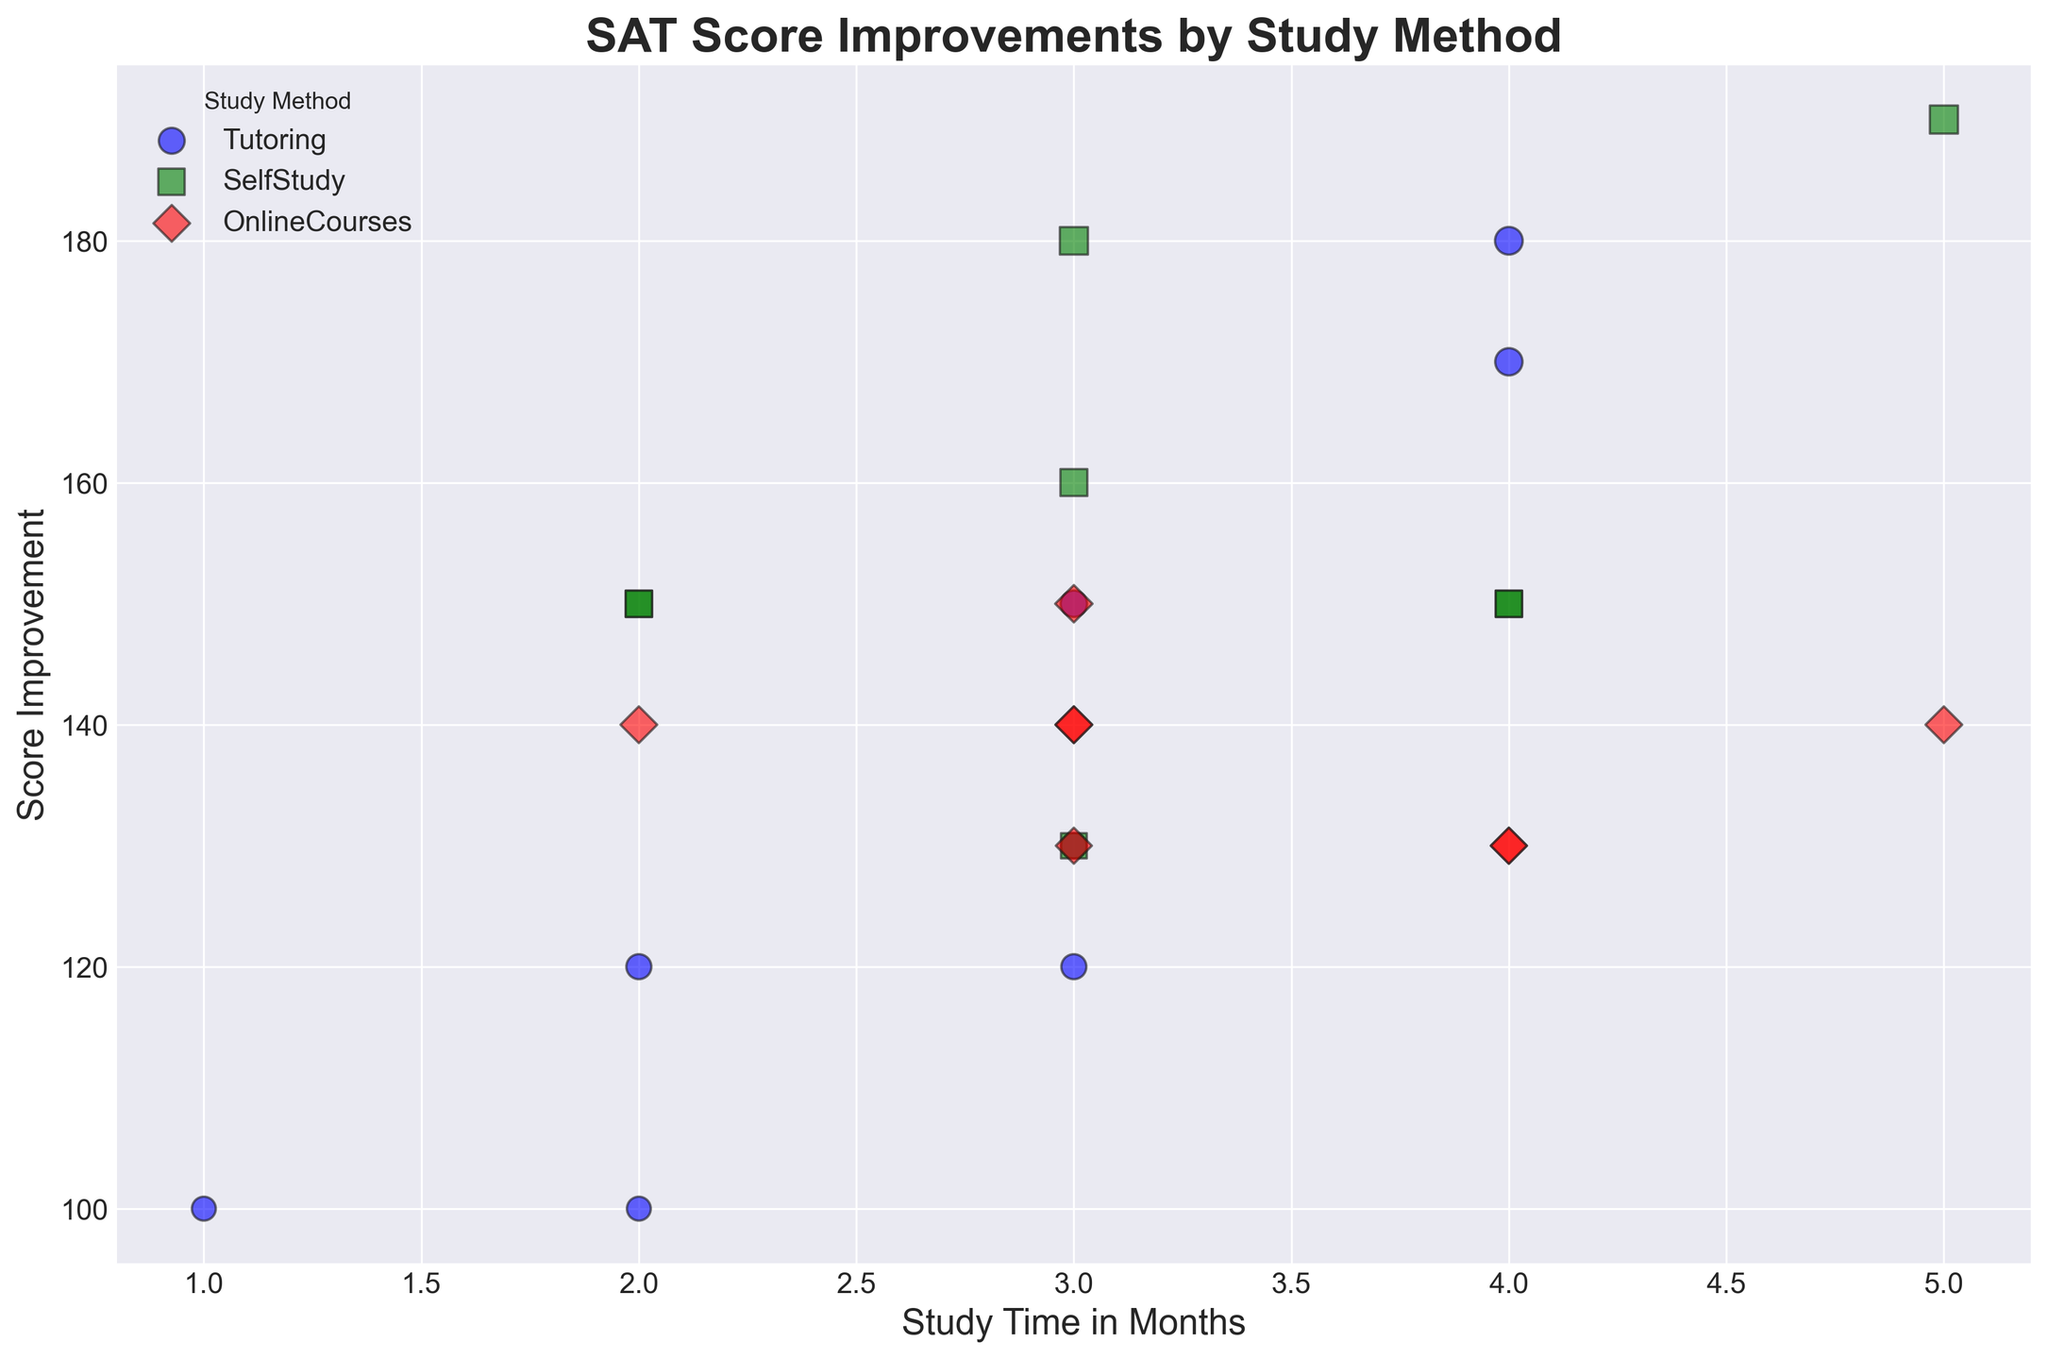What is the range of score improvements for students who used tutoring? First, locate the blue dots (representing tutoring) on the plot. Identify the highest and lowest values among the vertical (score improvement) values of these blue dots. The range is the difference between the maximum and minimum score improvements among these students.
Answer: 100-150 Which study method shows the greatest improvement in SAT scores? Examine the plot and compare the topmost dots (representing the maximum improvements) across all three colors (blue for Tutoring, green for SelfStudy, red for OnlineCourses). The color with the highest vertical position will indicate the study method with the greatest improvement.
Answer: Tutoring What is the average score improvement for students using Online Courses? Identify the red diamonds in the plot. Look at each red dot's vertical position to determine the respective score improvements. Sum these improvements and then divide by the total number of red diamonds (representing the number of Online Courses students) to find the average.
Answer: 130 Among all study methods, which one has the smallest score improvement? Compare the lowest points of all three colors (representing Tutoring, SelfStudy, and OnlineCourses) on the vertical axis. The one with the lowest position provides the smallest score improvement.
Answer: SelfStudy For study method "SelfStudy", what is the average study time in months? Identify the green squares representing SelfStudy students on the plot. Sum the horizontal positions (study times) of these green squares and divide by the total number of green squares to find the average study time.
Answer: 3 months What is the general trend of score improvement as study time increases for all methods combined? Observe the overall distribution of points and their vertical positions concerning the horizontal study time axis. Look for a pattern suggesting whether points generally move higher (greater improvements) as they move right (more study time).
Answer: Increasing Which study method appears to be the most consistent in terms of score improvements? Assess the spread or clustering of each color's dots. The method with the least spread in its vertical positions (i.e., the cluster is tight) indicates greater consistency.
Answer: Tutoring For students using Tutoring, which data point indicates the largest score improvement with the least study time? Among the blue dots, find the one that is highest on the vertical axis while being closest to the left (minimum study time).
Answer: 100 improvement in 1 month Do students using Online Courses show more variability in score improvements compared to those using SelfStudy? Compare the vertical spread (range of score improvements) of red diamonds (OnlineCourses) versus green squares (SelfStudy). More spread indicates more variability.
Answer: Yes 